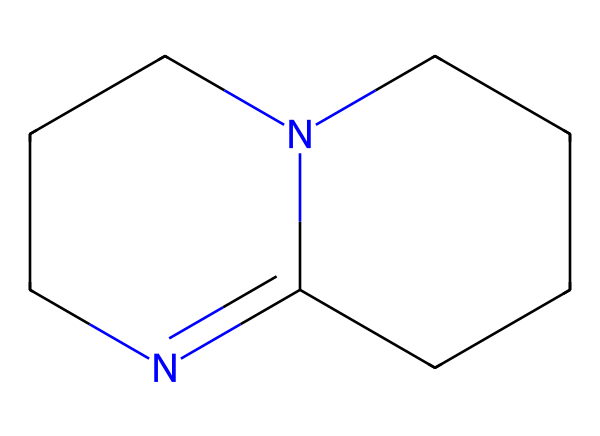What is the molecular formula of DBU? To find the molecular formula, we analyze the SMILES representation. The structure contains 11 carbons (C), 16 hydrogens (H), and 2 nitrogens (N), leading to the formula C11H16N2.
Answer: C11H16N2 How many nitrogen atoms are in DBU? By examining the SMILES representation, we can identify two nitrogen atoms present in the structure. They are indicated by the letter 'N' in the formula.
Answer: 2 What type of chemical structure is DBU? DBU is classified as a bicyclic compound due to its two interconnected ring structures as indicated in the SMILES representation.
Answer: bicyclic What is the pKa of DBU? The pKa of DBU, a measure of its basicity, is typically reported to be around 13.6. This reflects its capacity as a superbase.
Answer: 13.6 Does DBU contain any pi bonds? In the SMILES representation, one can identify the presence of a double bond between two carbon atoms, indicating the existence of pi bonds in the structure.
Answer: yes What functional groups are present in DBU? Analyzing the structure shows that DBU includes amine functional groups, as revealed by the nitrogen atoms linked to carbon atoms.
Answer: amines Is DBU a strong or weak base? Given its high pKa value and structure, DBU is identified as a strong base, confirmed by its effective use in various cleaning solutions.
Answer: strong 